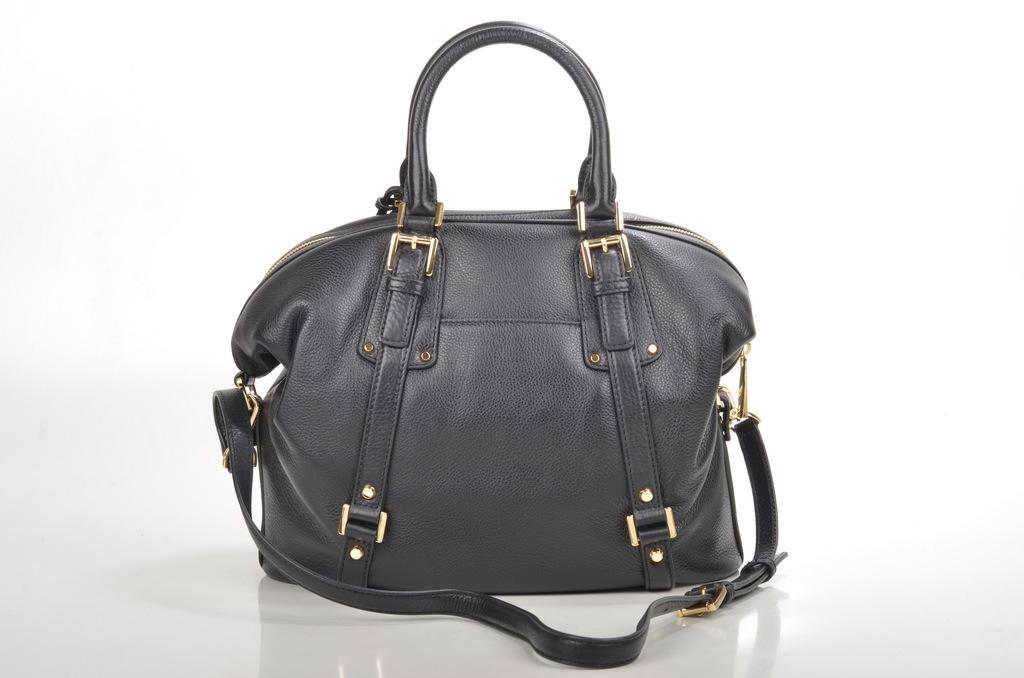How would you summarize this image in a sentence or two? There is a beautiful black hand back on which gold color chains are placed and it has a zip on top of it and there is a U shaped partition is there to hold the bag. 